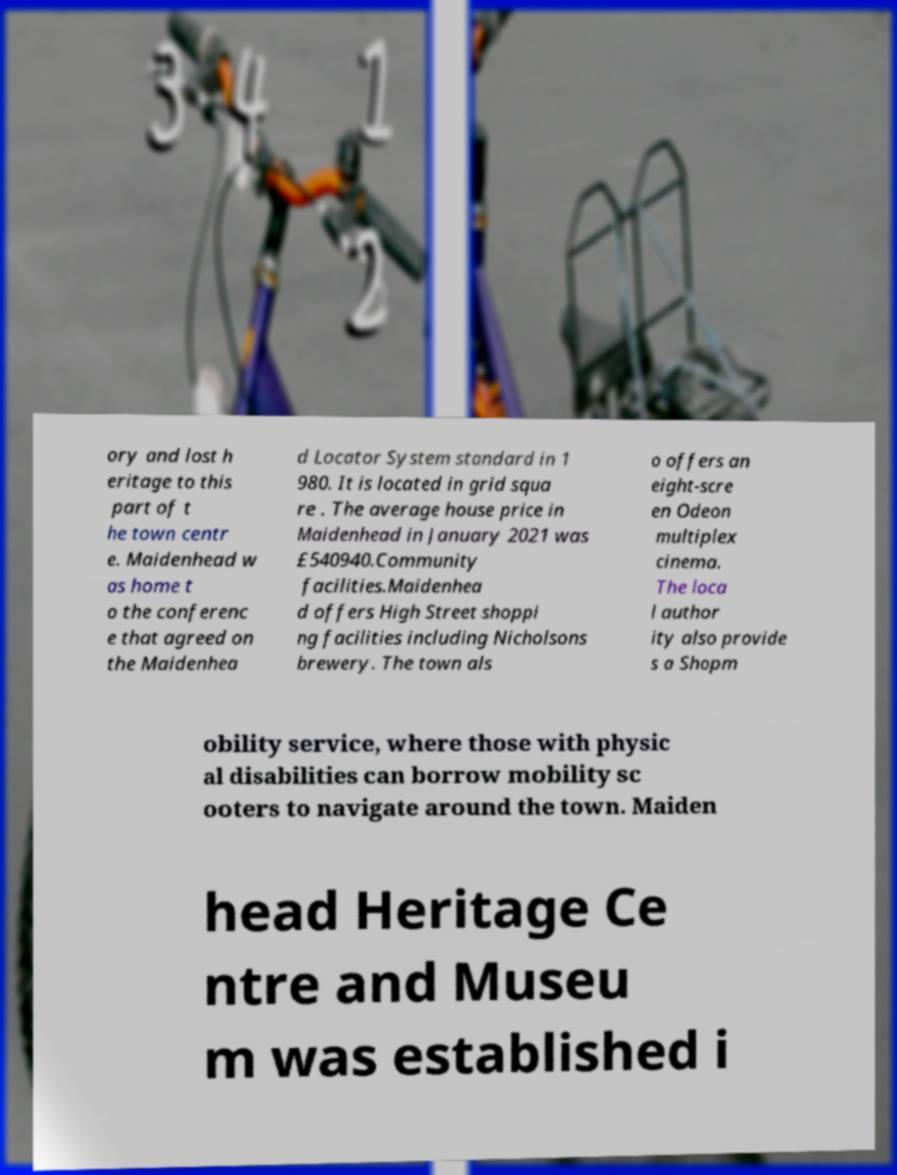There's text embedded in this image that I need extracted. Can you transcribe it verbatim? ory and lost h eritage to this part of t he town centr e. Maidenhead w as home t o the conferenc e that agreed on the Maidenhea d Locator System standard in 1 980. It is located in grid squa re . The average house price in Maidenhead in January 2021 was £540940.Community facilities.Maidenhea d offers High Street shoppi ng facilities including Nicholsons brewery. The town als o offers an eight-scre en Odeon multiplex cinema. The loca l author ity also provide s a Shopm obility service, where those with physic al disabilities can borrow mobility sc ooters to navigate around the town. Maiden head Heritage Ce ntre and Museu m was established i 